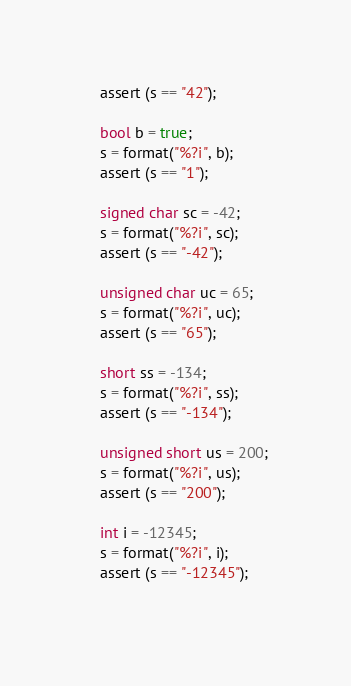<code> <loc_0><loc_0><loc_500><loc_500><_C++_>	assert (s == "42");
	
	bool b = true;
	s = format("%?i", b);
	assert (s == "1");

	signed char sc = -42;
	s = format("%?i", sc);
	assert (s == "-42");
	
	unsigned char uc = 65;
	s = format("%?i", uc);
	assert (s == "65");
	
	short ss = -134;
	s = format("%?i", ss);
	assert (s == "-134");
	
	unsigned short us = 200;
	s = format("%?i", us);
	assert (s == "200");
	
	int i = -12345;
	s = format("%?i", i);
	assert (s == "-12345");
	</code> 